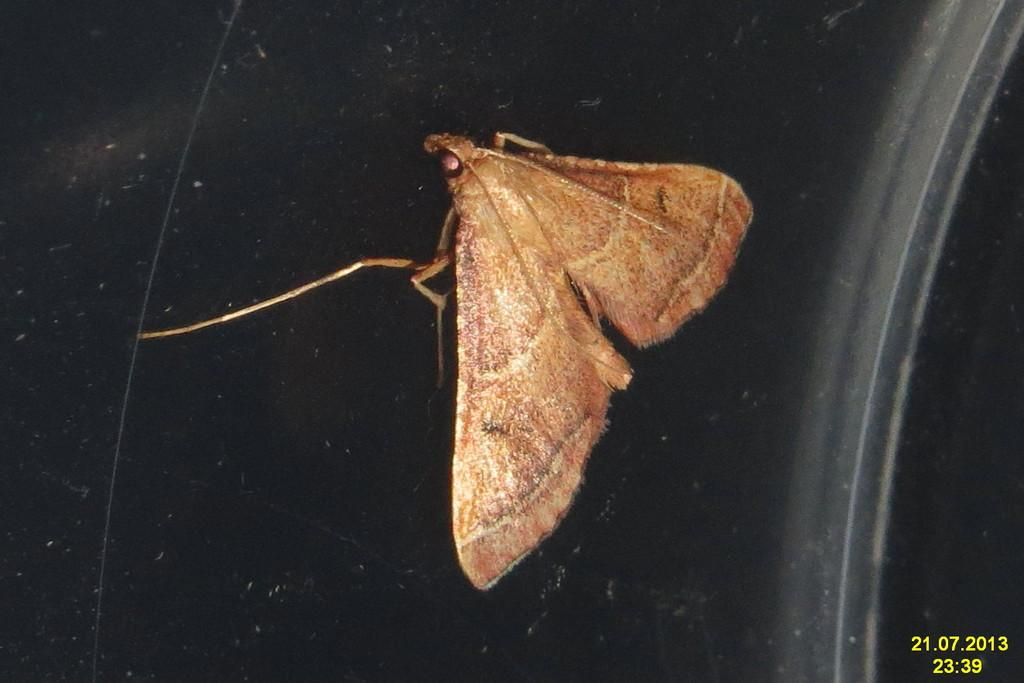What type of creature is present in the image? There is an insect in the image. What is the background or surface that the insect is on? The insect is on a black surface. Can you provide any additional information about the image? The date and time are displayed in numbers at the bottom right side of the image. What type of substance does the insect taste like in the image? There is no information about the taste of the insect or any substance in the image. 